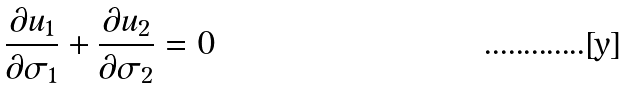<formula> <loc_0><loc_0><loc_500><loc_500>\frac { \partial { u _ { 1 } } } { \partial { \sigma _ { 1 } } } + \frac { \partial { u _ { 2 } } } { \partial { \sigma _ { 2 } } } = 0</formula> 